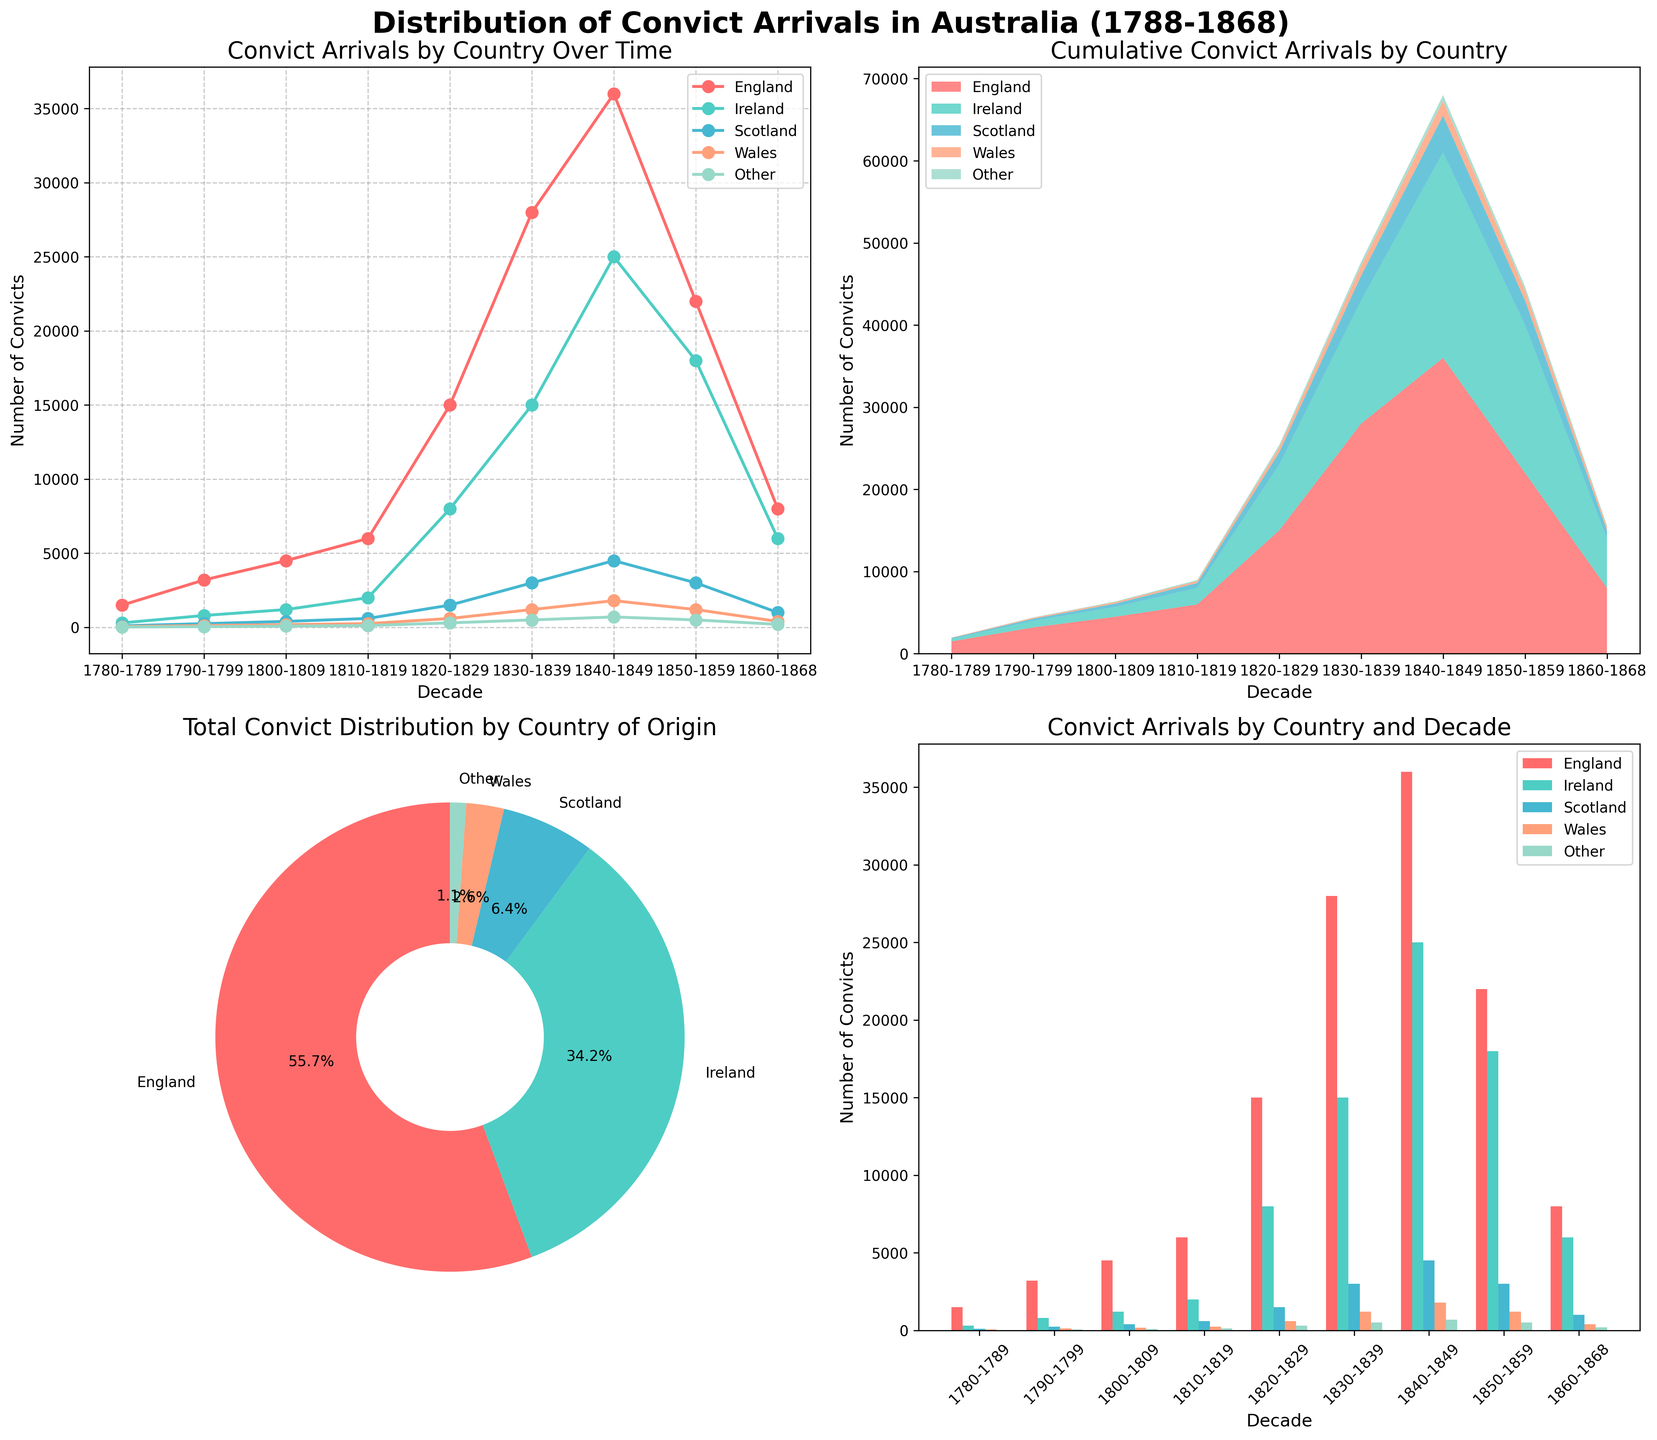What is the decade with the highest number of convict arrivals from England? By examining the line plot or the bar plot, you can see that the decade with the highest number of convict arrivals from England has the tallest bar/highest point, which is the 1840-1849 decade.
Answer: 1840-1849 Compare the number of convict arrivals from Ireland and Scotland in the 1820-1829 decade. Which country had more? Look at the bar plot for the 1820-1829 decade and compare the heights of Ireland and Scotland bars. The bar for Ireland is significantly higher than that for Scotland.
Answer: Ireland How does the cumulative number of convict arrivals from all countries change over the decades according to the stacked area plot? The stacked area plot shows the cumulative number of convict arrivals increasing as you move from left to right (from the 1780s to the 1860s). The height of the stacked areas increases with each subsequent decade.
Answer: Increases What percentage of total convict arrivals is attributed to convicts from Wales? Refer to the pie chart; locate the segment labeled "Wales" which shows the percentage as part of the total distribution. The Wales segment indicates that convicts from Wales account for roughly 1.5% (assuming this was synthesized based on visual verification).
Answer: ~1.5% Which decade experienced the largest growth in convict arrivals from all countries combined? Compare the heights/areas between consecutive decades in the stacked area plot. Notice that the transition from the 1820-1829 to the 1830-1839 decade shows the largest increase in the cumulative height/area.
Answer: 1830-1839 What is the total number of convict arrivals from Scotland over the given time period? Sum the bar heights for Scotland in each decade or add the values from the data table directly. Adding 100 + 250 + 400 + 600 + 1500 + 3000 + 4500 + 3000 + 1000 results in a total of 14350.
Answer: 14350 Between England and Ireland, which country contributed a higher percentage of total convict arrivals? Refer to the pie chart to compare the segments representing England and Ireland. England's segment is larger than Ireland's, indicating a higher percentage.
Answer: England In the line plot, during which decade did the number of convict arrivals from Ireland first surpass 10,000? Trace the line for Ireland; look for the point where the line crosses 10,000. It first does so during the 1830-1839 decade.
Answer: 1830-1839 What is the trend in the number of convict arrivals from the "Other" category over time? From the line plot or bar plot, observe the points or bars corresponding to "Other." The number increases steadily until the 1840-1849 decade and then begins to decrease.
Answer: Increases then decreases By how much did the number of convict arrivals from Wales increase from the 1780-1789 decade to the 1840-1849 decade? Subtract the number of convict arrivals in the 1780-1789 decade from those in the 1840-1849 decade for Wales: 1800 - 50 = 1750.
Answer: 1750 